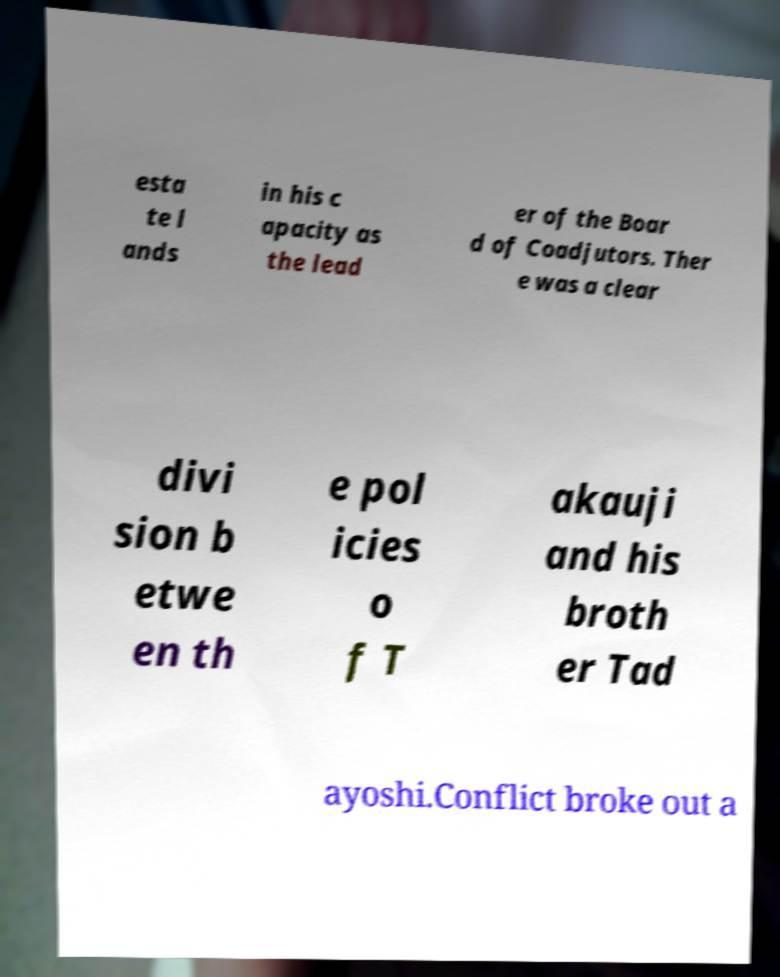Can you accurately transcribe the text from the provided image for me? esta te l ands in his c apacity as the lead er of the Boar d of Coadjutors. Ther e was a clear divi sion b etwe en th e pol icies o f T akauji and his broth er Tad ayoshi.Conflict broke out a 